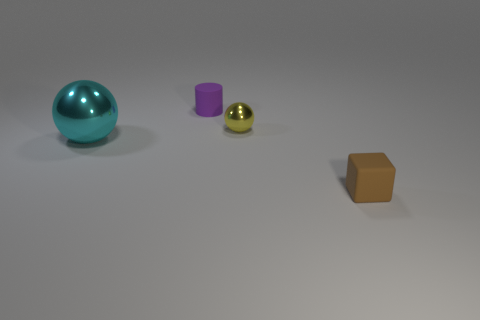What might the textures of these objects be like? The teal sphere appears to have a smooth, metallic texture, the purple cylinder looks matte, the small sphere has a shiny, polished surface, and the orange box seems to have a slightly rough, perhaps cardboard-like texture. 